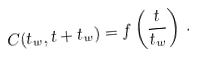Convert formula to latex. <formula><loc_0><loc_0><loc_500><loc_500>C ( t _ { w } , t + t _ { w } ) = f \left ( \frac { t } { t _ { w } } \right ) \, .</formula> 